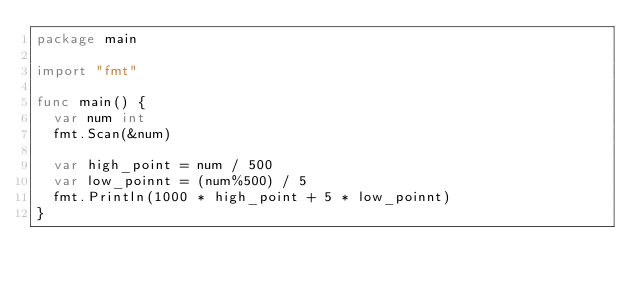Convert code to text. <code><loc_0><loc_0><loc_500><loc_500><_Go_>package main

import "fmt"

func main() {
	var num int
	fmt.Scan(&num)

	var high_point = num / 500
	var low_poinnt = (num%500) / 5
	fmt.Println(1000 * high_point + 5 * low_poinnt)
}</code> 